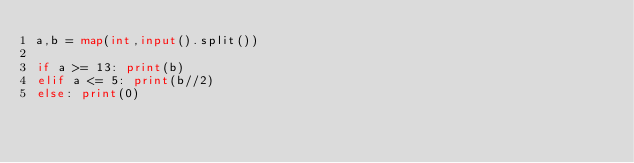<code> <loc_0><loc_0><loc_500><loc_500><_Python_>a,b = map(int,input().split())

if a >= 13: print(b)
elif a <= 5: print(b//2)
else: print(0)</code> 